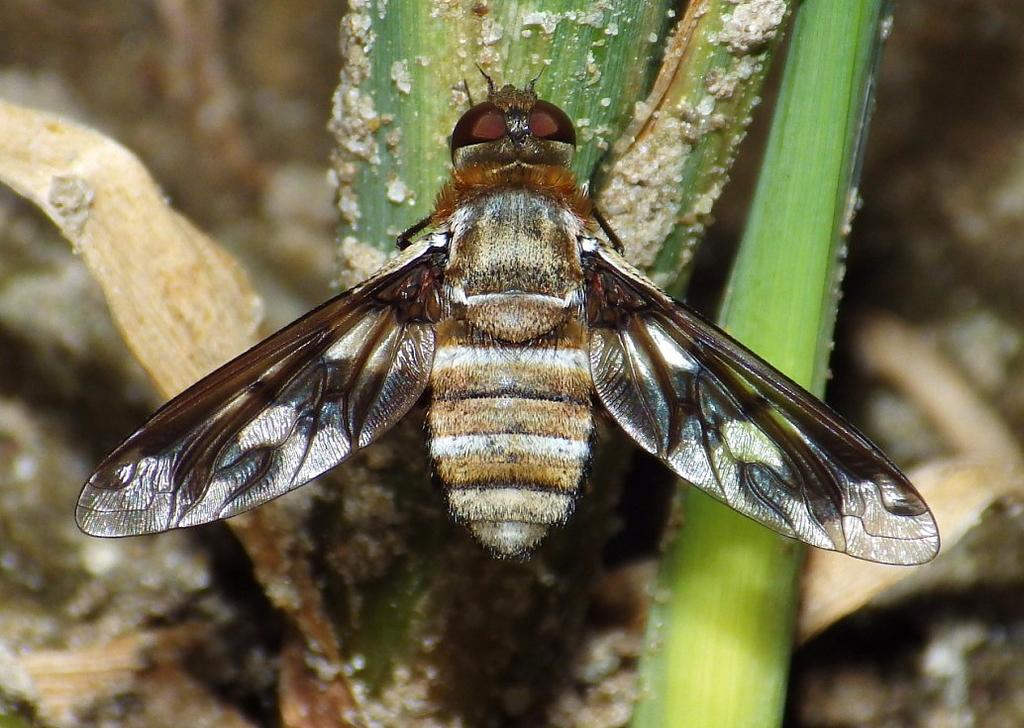Where was the image taken? The image was taken outdoors. What can be seen at the bottom of the image? There is a ground at the bottom of the image. What is located in the middle of the image? There is a plant in the middle of the image. Can you describe the plant in the image? There is a fly on the plant. What type of joke is the fly telling on the plant in the image? There is no joke being told in the image; it simply shows a fly on a plant. 